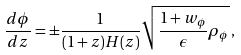Convert formula to latex. <formula><loc_0><loc_0><loc_500><loc_500>\frac { d \phi } { d z } = \pm \frac { 1 } { ( 1 + z ) H ( z ) } \sqrt { \frac { 1 + w _ { \phi } } { \epsilon } \rho _ { \phi } } \, ,</formula> 